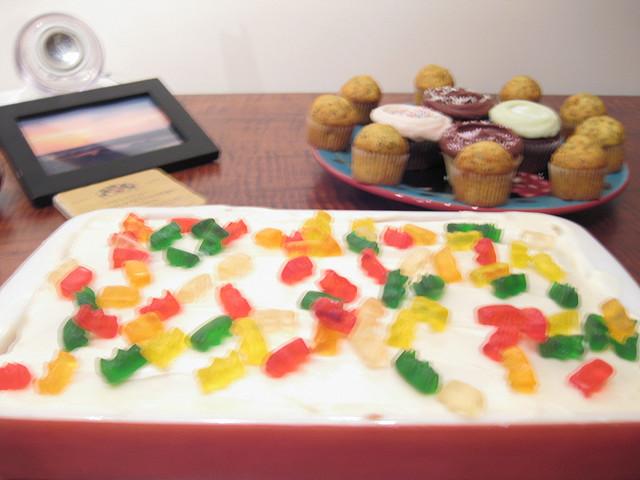What animal head is on the plate?
Short answer required. Bear. How many mini muffins are on the plate?
Be succinct. 9. What is the percentage of yellow gummy bears?
Keep it brief. 25%. What direction are the black lines on the table running?
Write a very short answer. Vertical. 